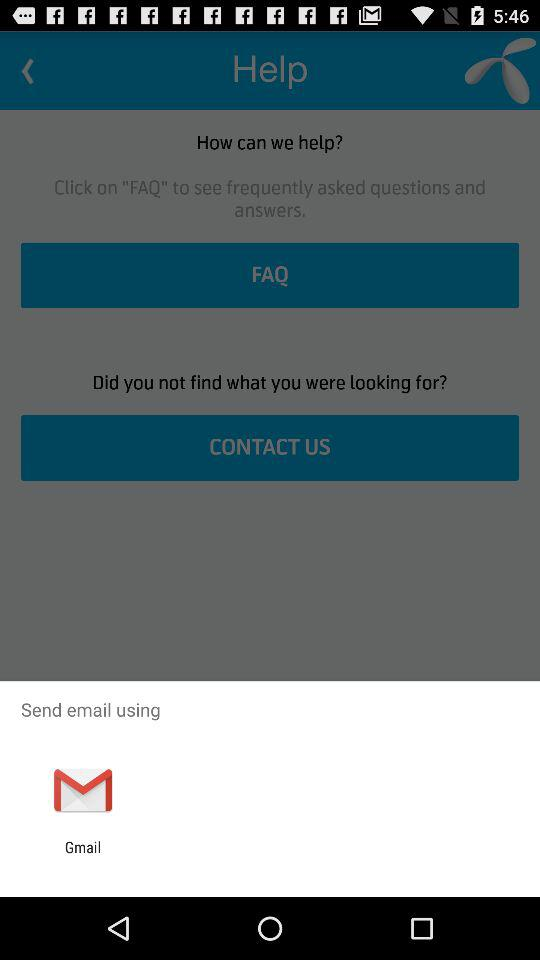What is the option to send the email? The option to send the email is "Gmail". 